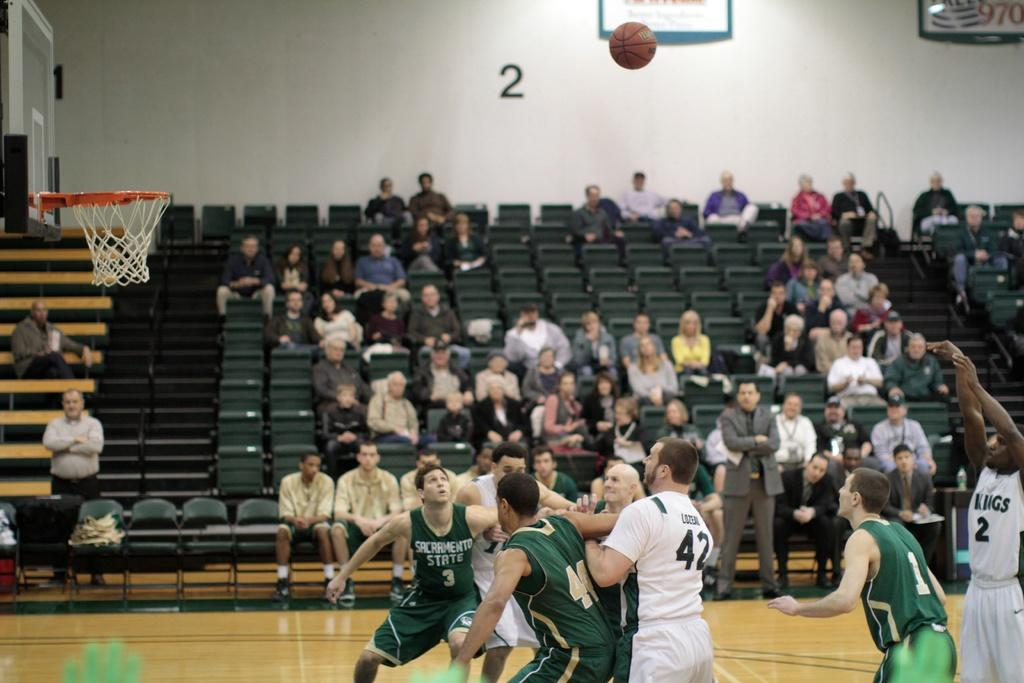<image>
Give a short and clear explanation of the subsequent image. a basketball game between sacramento state and the kings 